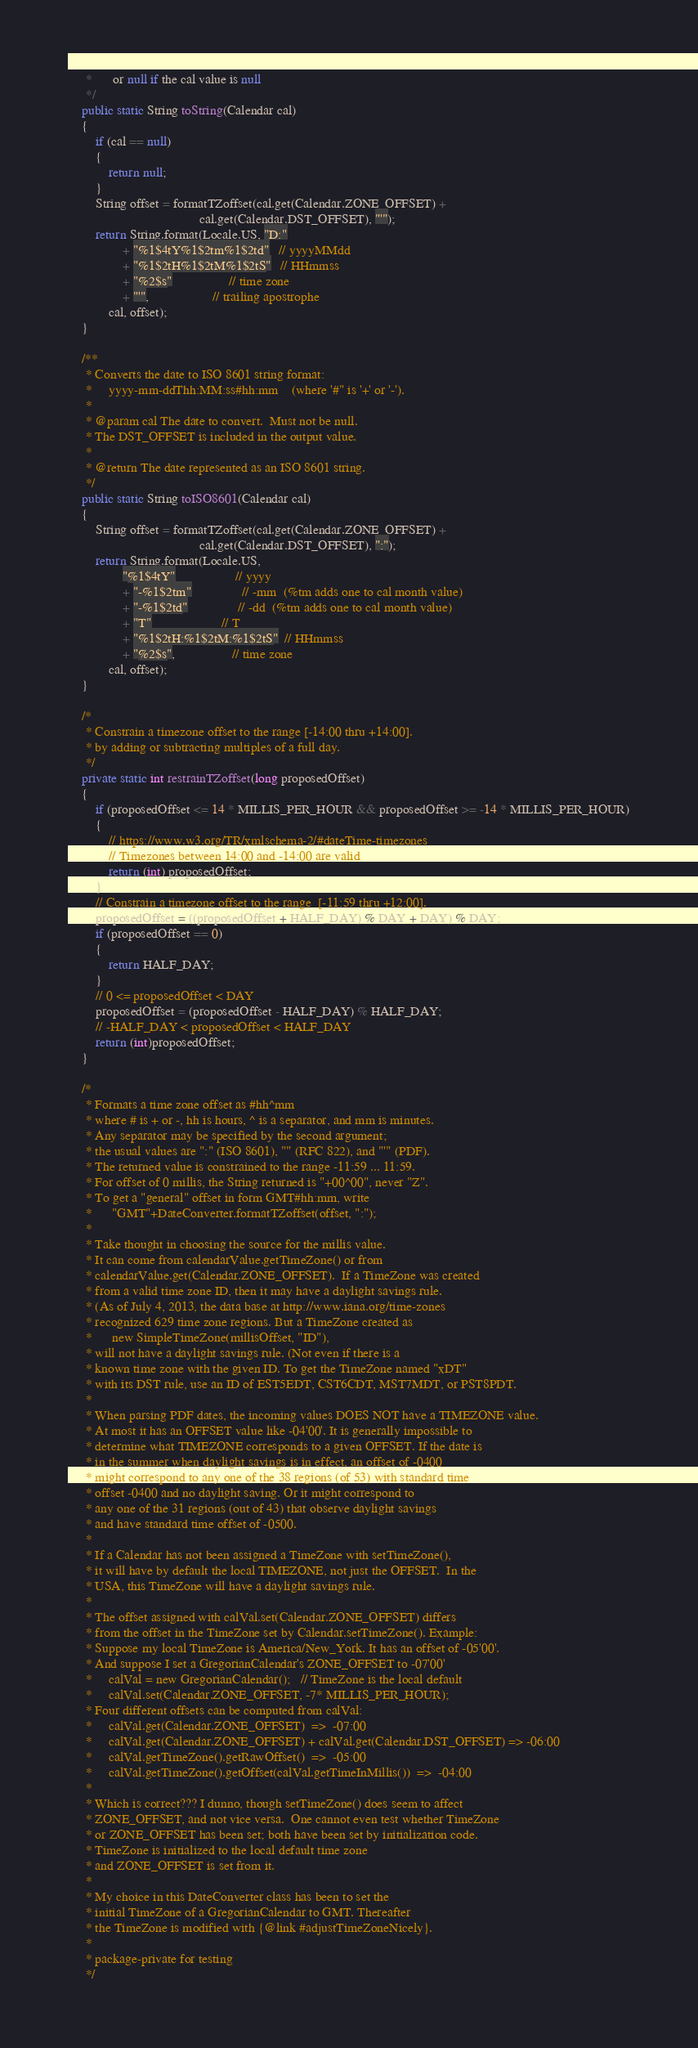Convert code to text. <code><loc_0><loc_0><loc_500><loc_500><_Java_>     *      or null if the cal value is null
     */
    public static String toString(Calendar cal)
    {
        if (cal == null) 
        {
            return null;
        }
        String offset = formatTZoffset(cal.get(Calendar.ZONE_OFFSET) +
                                       cal.get(Calendar.DST_OFFSET), "'");
        return String.format(Locale.US, "D:"
                + "%1$4tY%1$2tm%1$2td"   // yyyyMMdd 
                + "%1$2tH%1$2tM%1$2tS"   // HHmmss 
                + "%2$s"                 // time zone
                + "'",                   // trailing apostrophe
            cal, offset);
    }

    /**
     * Converts the date to ISO 8601 string format:
     *     yyyy-mm-ddThh:MM:ss#hh:mm    (where '#" is '+' or '-').
     *
     * @param cal The date to convert.  Must not be null.
     * The DST_OFFSET is included in the output value.
     * 
     * @return The date represented as an ISO 8601 string.
     */
    public static String toISO8601(Calendar cal)
    {
        String offset = formatTZoffset(cal.get(Calendar.ZONE_OFFSET) +
                                       cal.get(Calendar.DST_OFFSET), ":");
        return String.format(Locale.US, 
                "%1$4tY"                  // yyyy
                + "-%1$2tm"               // -mm  (%tm adds one to cal month value)
                + "-%1$2td"               // -dd  (%tm adds one to cal month value)
                + "T"                     // T
                + "%1$2tH:%1$2tM:%1$2tS"  // HHmmss
                + "%2$s",                 // time zone
            cal, offset);
    }
    
    /*
     * Constrain a timezone offset to the range [-14:00 thru +14:00].
     * by adding or subtracting multiples of a full day.
     */
    private static int restrainTZoffset(long proposedOffset)
    {
        if (proposedOffset <= 14 * MILLIS_PER_HOUR && proposedOffset >= -14 * MILLIS_PER_HOUR)
        {
            // https://www.w3.org/TR/xmlschema-2/#dateTime-timezones
            // Timezones between 14:00 and -14:00 are valid
            return (int) proposedOffset;
        }
        // Constrain a timezone offset to the range  [-11:59 thru +12:00].
        proposedOffset = ((proposedOffset + HALF_DAY) % DAY + DAY) % DAY;
        if (proposedOffset == 0)
        {
            return HALF_DAY;
        }
        // 0 <= proposedOffset < DAY
        proposedOffset = (proposedOffset - HALF_DAY) % HALF_DAY;
        // -HALF_DAY < proposedOffset < HALF_DAY
        return (int)proposedOffset;
    }
    
    /*
     * Formats a time zone offset as #hh^mm
     * where # is + or -, hh is hours, ^ is a separator, and mm is minutes.
     * Any separator may be specified by the second argument;
     * the usual values are ":" (ISO 8601), "" (RFC 822), and "'" (PDF).
     * The returned value is constrained to the range -11:59 ... 11:59.
     * For offset of 0 millis, the String returned is "+00^00", never "Z".
     * To get a "general" offset in form GMT#hh:mm, write
     *      "GMT"+DateConverter.formatTZoffset(offset, ":");
     *
     * Take thought in choosing the source for the millis value. 
     * It can come from calendarValue.getTimeZone() or from 
     * calendarValue.get(Calendar.ZONE_OFFSET).  If a TimeZone was created
     * from a valid time zone ID, then it may have a daylight savings rule.
     * (As of July 4, 2013, the data base at http://www.iana.org/time-zones 
     * recognized 629 time zone regions. But a TimeZone created as 
     *      new SimpleTimeZone(millisOffset, "ID"), 
     * will not have a daylight savings rule. (Not even if there is a
     * known time zone with the given ID. To get the TimeZone named "xDT"
     * with its DST rule, use an ID of EST5EDT, CST6CDT, MST7MDT, or PST8PDT.
     *
     * When parsing PDF dates, the incoming values DOES NOT have a TIMEZONE value.
     * At most it has an OFFSET value like -04'00'. It is generally impossible to 
     * determine what TIMEZONE corresponds to a given OFFSET. If the date is
     * in the summer when daylight savings is in effect, an offset of -0400
     * might correspond to any one of the 38 regions (of 53) with standard time 
     * offset -0400 and no daylight saving. Or it might correspond to 
     * any one of the 31 regions (out of 43) that observe daylight savings 
     * and have standard time offset of -0500.
     *
     * If a Calendar has not been assigned a TimeZone with setTimeZone(), 
     * it will have by default the local TIMEZONE, not just the OFFSET.  In the
     * USA, this TimeZone will have a daylight savings rule.
     *
     * The offset assigned with calVal.set(Calendar.ZONE_OFFSET) differs
     * from the offset in the TimeZone set by Calendar.setTimeZone(). Example:
     * Suppose my local TimeZone is America/New_York. It has an offset of -05'00'.
     * And suppose I set a GregorianCalendar's ZONE_OFFSET to -07'00'
     *     calVal = new GregorianCalendar();   // TimeZone is the local default
     *     calVal.set(Calendar.ZONE_OFFSET, -7* MILLIS_PER_HOUR);
     * Four different offsets can be computed from calVal:
     *     calVal.get(Calendar.ZONE_OFFSET)  =>  -07:00
     *     calVal.get(Calendar.ZONE_OFFSET) + calVal.get(Calendar.DST_OFFSET) => -06:00
     *     calVal.getTimeZone().getRawOffset()  =>  -05:00
     *     calVal.getTimeZone().getOffset(calVal.getTimeInMillis())  =>  -04:00
     *
     * Which is correct??? I dunno, though setTimeZone() does seem to affect
     * ZONE_OFFSET, and not vice versa.  One cannot even test whether TimeZone 
     * or ZONE_OFFSET has been set; both have been set by initialization code.
     * TimeZone is initialized to the local default time zone 
     * and ZONE_OFFSET is set from it.
     * 
     * My choice in this DateConverter class has been to set the 
     * initial TimeZone of a GregorianCalendar to GMT. Thereafter
     * the TimeZone is modified with {@link #adjustTimeZoneNicely}.
     *
     * package-private for testing
     */</code> 